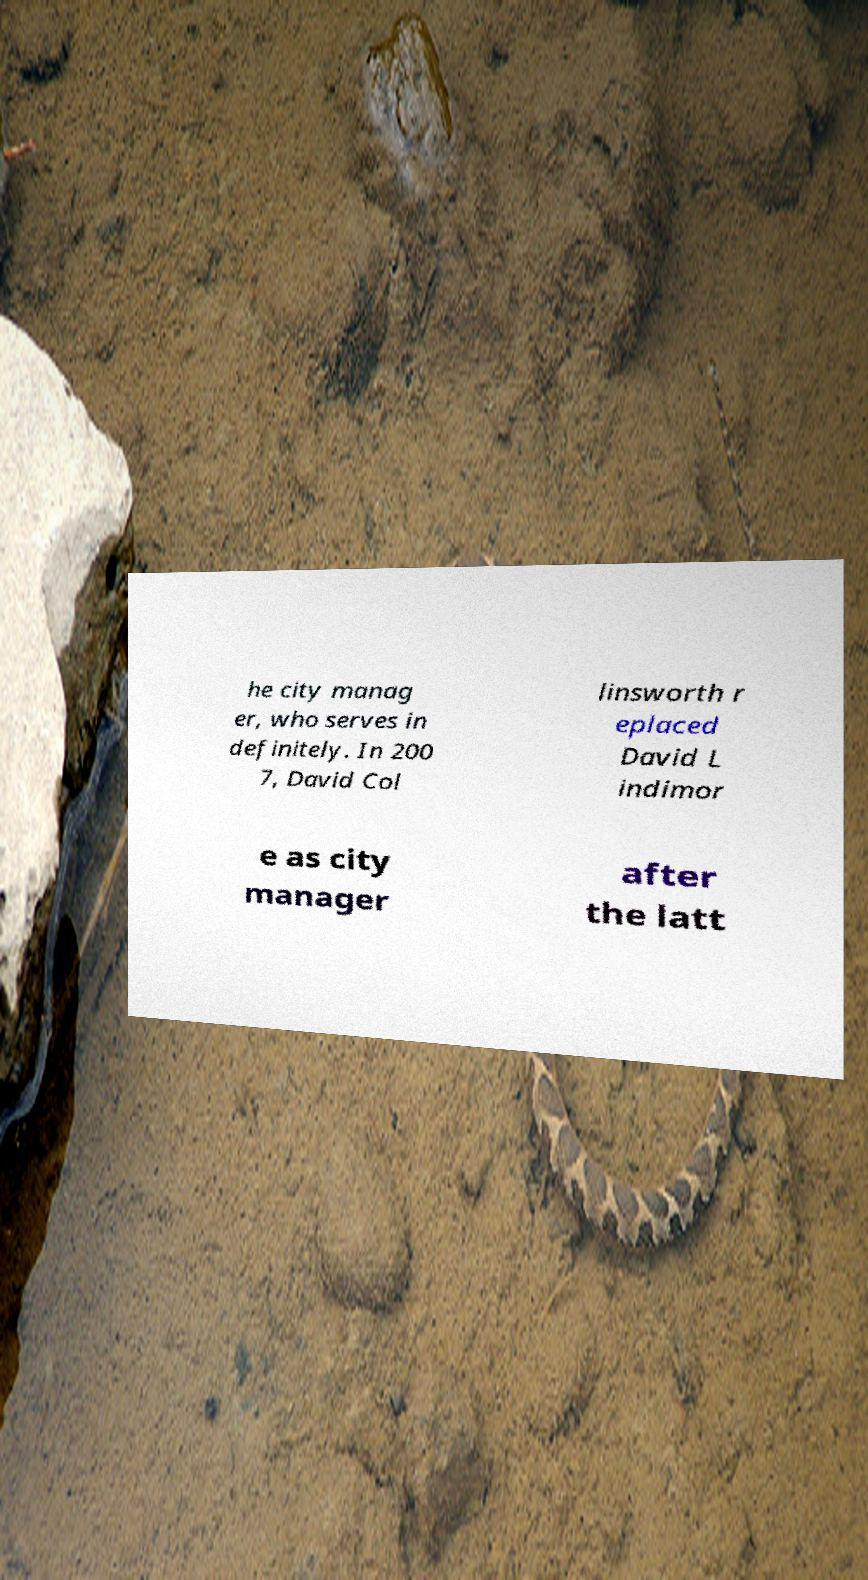Can you accurately transcribe the text from the provided image for me? he city manag er, who serves in definitely. In 200 7, David Col linsworth r eplaced David L indimor e as city manager after the latt 